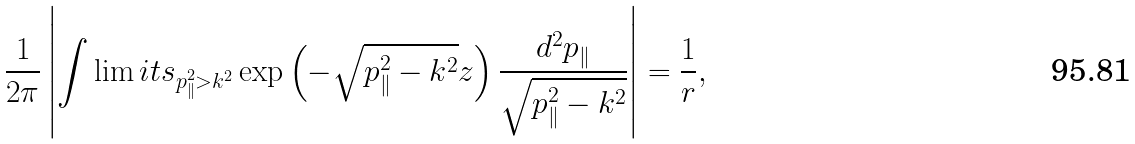<formula> <loc_0><loc_0><loc_500><loc_500>\frac { 1 } { 2 \pi } \left | \int \lim i t s _ { p _ { \| } ^ { 2 } > k ^ { 2 } } \exp \left ( - \sqrt { p _ { \| } ^ { 2 } - k ^ { 2 } } z \right ) \frac { d ^ { 2 } p _ { \| } } { \sqrt { p _ { \| } ^ { 2 } - k ^ { 2 } } } \right | = \frac { 1 } { r } ,</formula> 